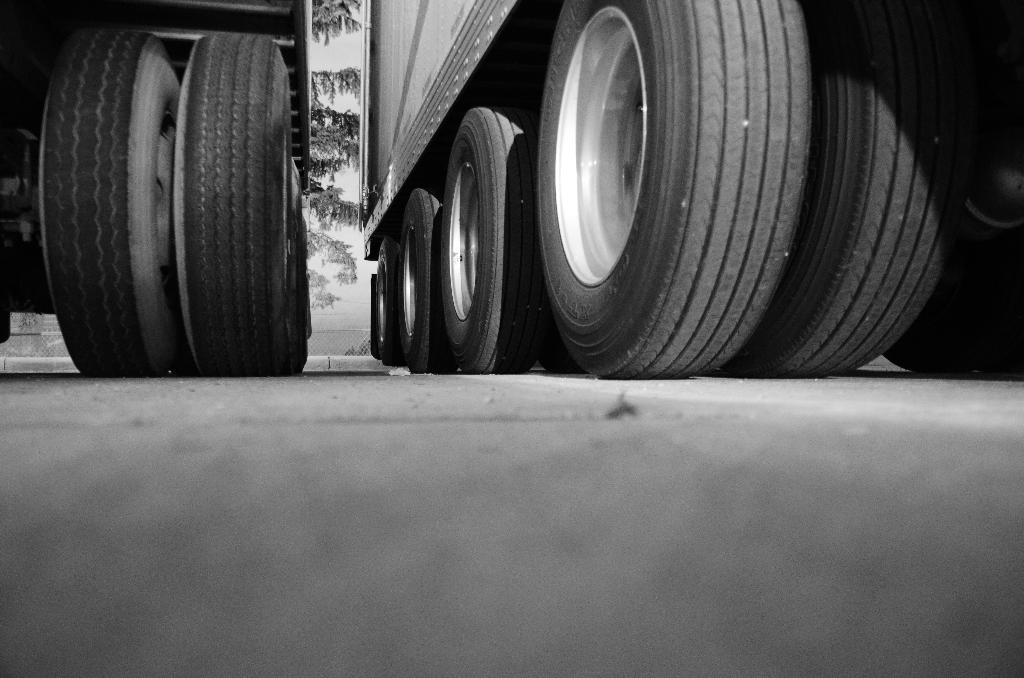What objects are present in the image related to vehicles? There are tyres of two vehicles in the image. What can be seen in the background of the image? There are trees visible behind the vehicles. How much salt is present on the tyres of the vehicles in the image? There is no salt present on the tyres of the vehicles in the image. What type of spoon can be seen interacting with the tyres in the image? There is no spoon present in the image, interacting with the tyres or otherwise. 